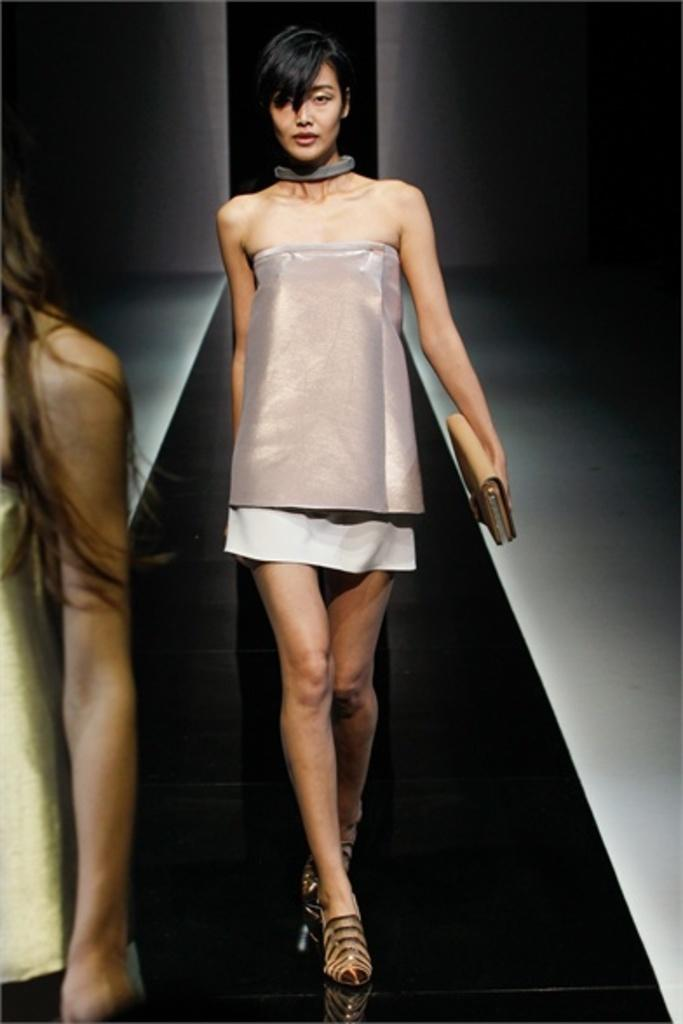What is happening in the foreground of the image? There is a person in front of the image. What is happening behind the first person? There is another person walking behind the first person. What is the second person holding? The second person is holding a wallet. What can be seen in the background of the image? There is a wall in the background of the image. Where is the throne located in the image? There is no throne present in the image. What is the size of the mom in the image? There is no mention of a mom in the image, so we cannot determine her size. 